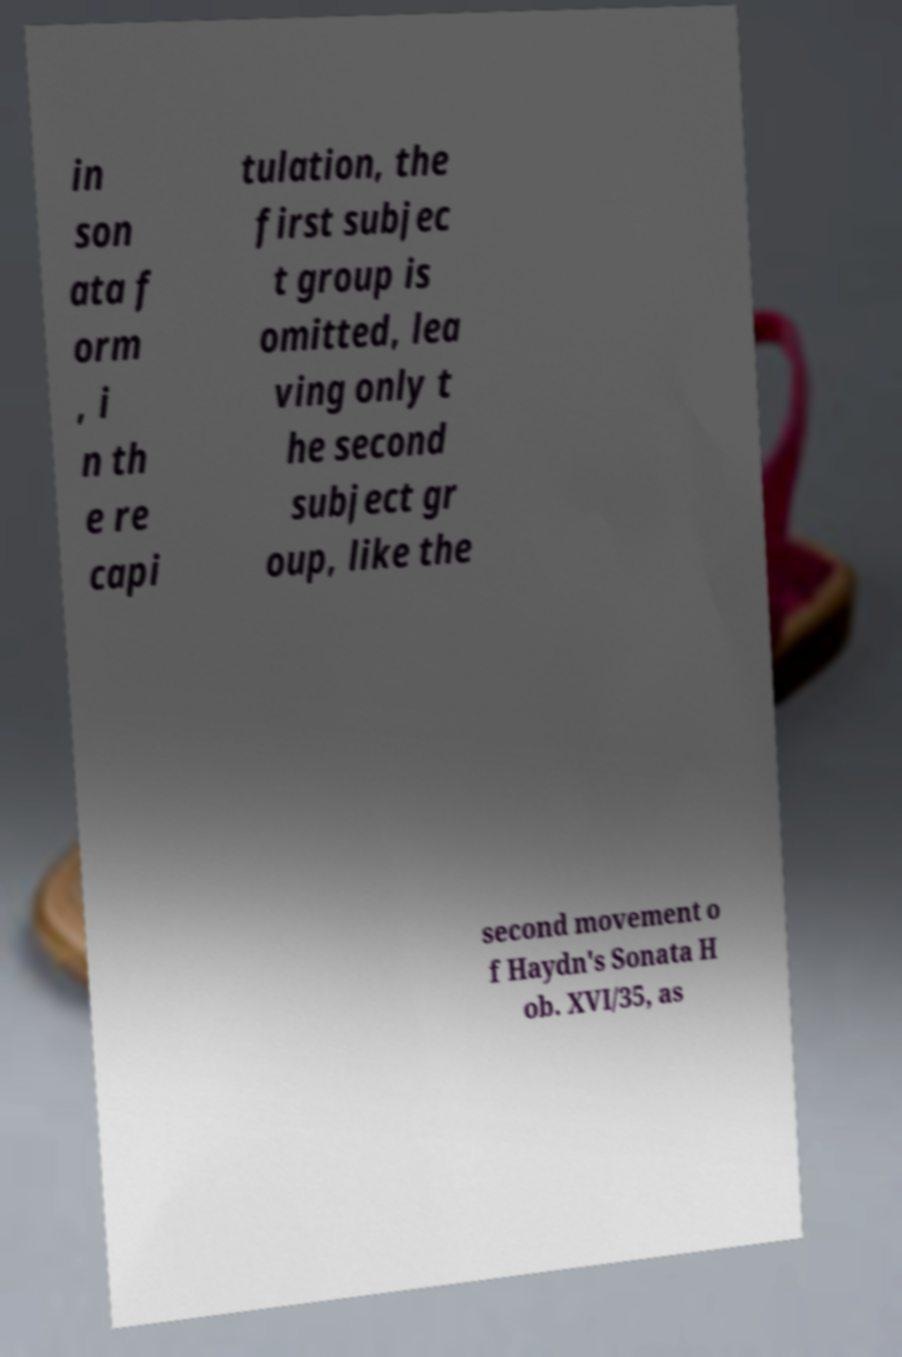What messages or text are displayed in this image? I need them in a readable, typed format. in son ata f orm , i n th e re capi tulation, the first subjec t group is omitted, lea ving only t he second subject gr oup, like the second movement o f Haydn's Sonata H ob. XVI/35, as 